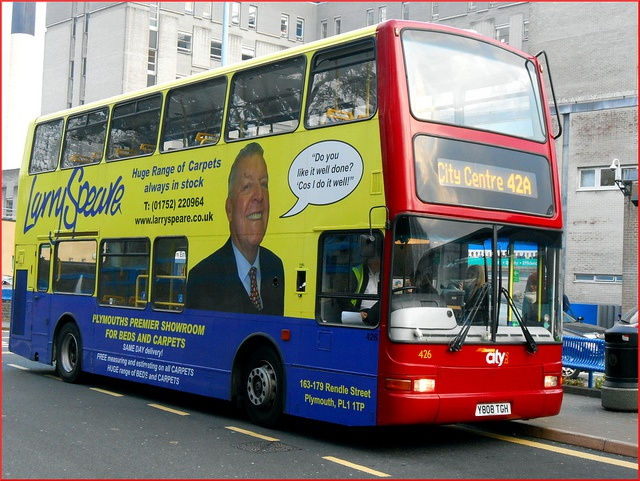Describe the objects in this image and their specific colors. I can see bus in red, black, gray, navy, and lightgray tones, people in red, black, and gray tones, people in red, black, darkgray, gray, and darkgreen tones, bench in red, blue, navy, darkblue, and lightblue tones, and people in red, black, gray, and darkgreen tones in this image. 